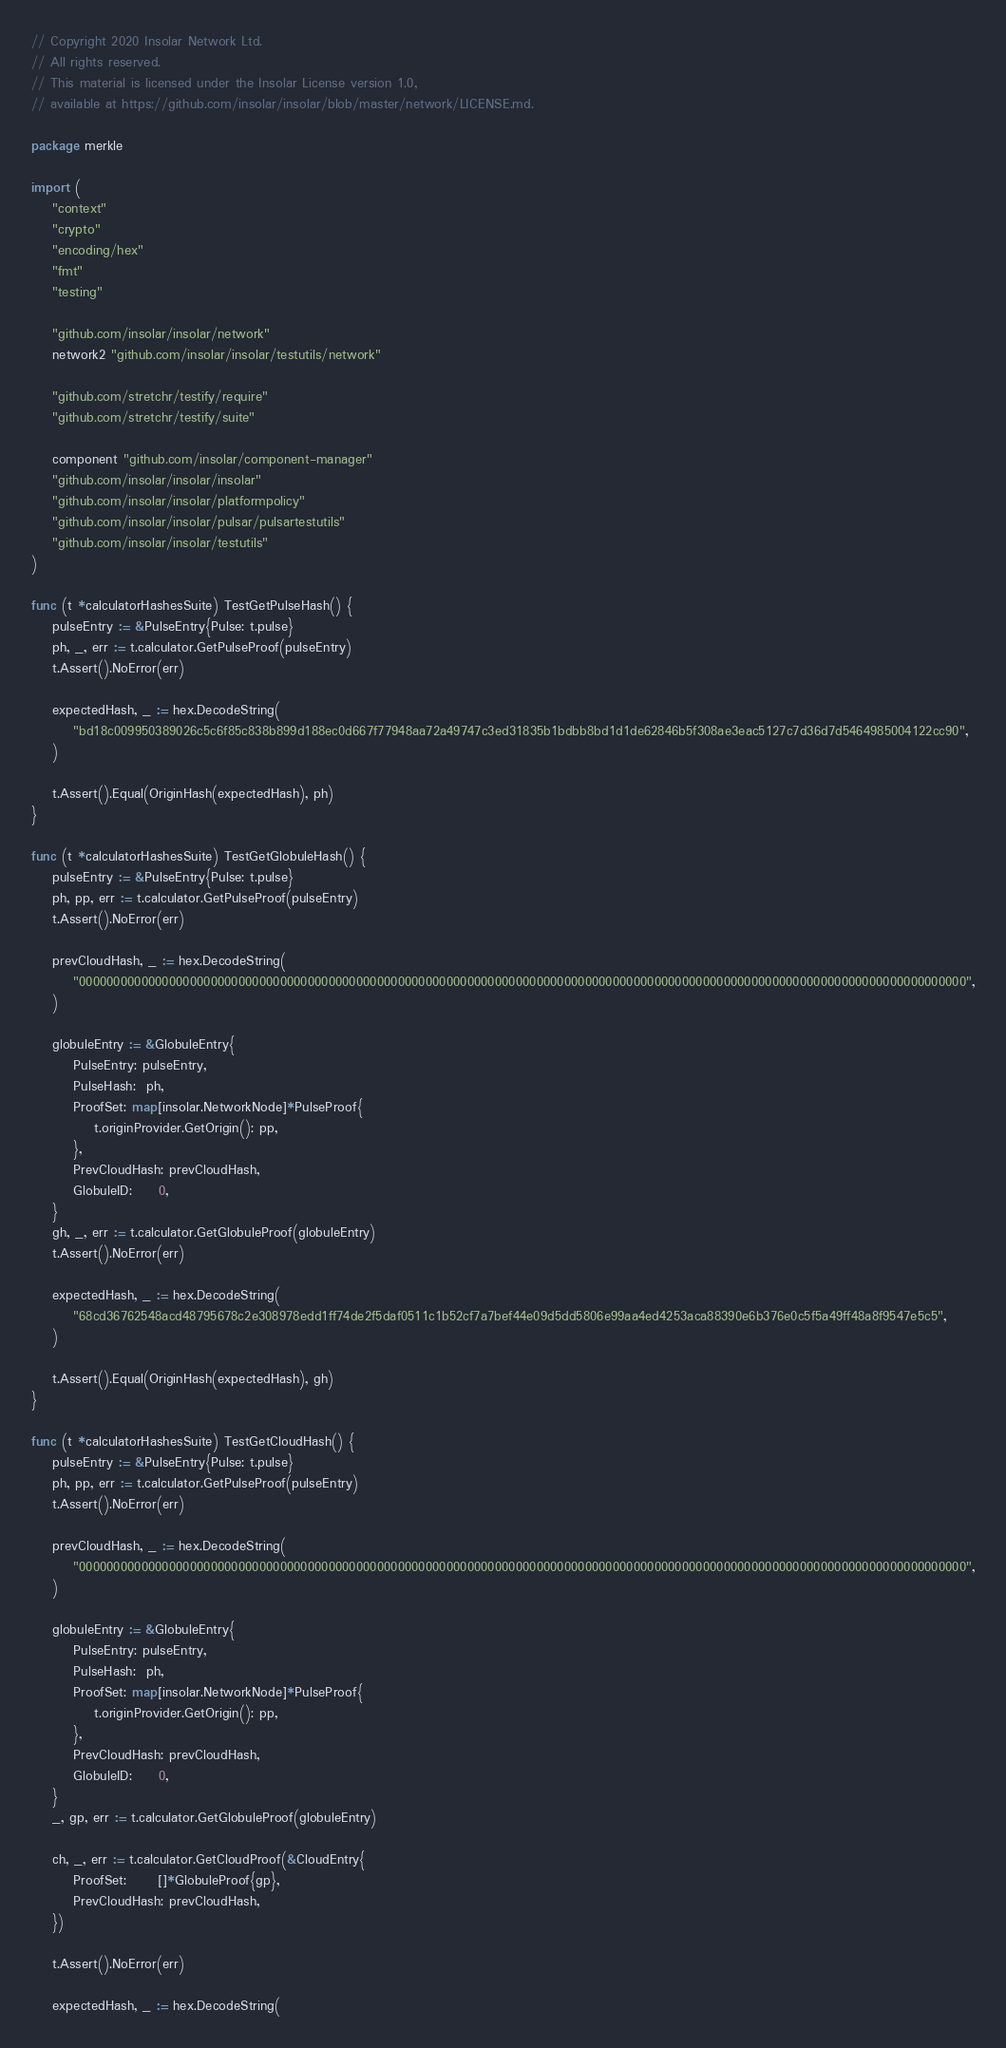<code> <loc_0><loc_0><loc_500><loc_500><_Go_>// Copyright 2020 Insolar Network Ltd.
// All rights reserved.
// This material is licensed under the Insolar License version 1.0,
// available at https://github.com/insolar/insolar/blob/master/network/LICENSE.md.

package merkle

import (
	"context"
	"crypto"
	"encoding/hex"
	"fmt"
	"testing"

	"github.com/insolar/insolar/network"
	network2 "github.com/insolar/insolar/testutils/network"

	"github.com/stretchr/testify/require"
	"github.com/stretchr/testify/suite"

	component "github.com/insolar/component-manager"
	"github.com/insolar/insolar/insolar"
	"github.com/insolar/insolar/platformpolicy"
	"github.com/insolar/insolar/pulsar/pulsartestutils"
	"github.com/insolar/insolar/testutils"
)

func (t *calculatorHashesSuite) TestGetPulseHash() {
	pulseEntry := &PulseEntry{Pulse: t.pulse}
	ph, _, err := t.calculator.GetPulseProof(pulseEntry)
	t.Assert().NoError(err)

	expectedHash, _ := hex.DecodeString(
		"bd18c009950389026c5c6f85c838b899d188ec0d667f77948aa72a49747c3ed31835b1bdbb8bd1d1de62846b5f308ae3eac5127c7d36d7d5464985004122cc90",
	)

	t.Assert().Equal(OriginHash(expectedHash), ph)
}

func (t *calculatorHashesSuite) TestGetGlobuleHash() {
	pulseEntry := &PulseEntry{Pulse: t.pulse}
	ph, pp, err := t.calculator.GetPulseProof(pulseEntry)
	t.Assert().NoError(err)

	prevCloudHash, _ := hex.DecodeString(
		"00000000000000000000000000000000000000000000000000000000000000000000000000000000000000000000000000000000000000000000000000000000",
	)

	globuleEntry := &GlobuleEntry{
		PulseEntry: pulseEntry,
		PulseHash:  ph,
		ProofSet: map[insolar.NetworkNode]*PulseProof{
			t.originProvider.GetOrigin(): pp,
		},
		PrevCloudHash: prevCloudHash,
		GlobuleID:     0,
	}
	gh, _, err := t.calculator.GetGlobuleProof(globuleEntry)
	t.Assert().NoError(err)

	expectedHash, _ := hex.DecodeString(
		"68cd36762548acd48795678c2e308978edd1ff74de2f5daf0511c1b52cf7a7bef44e09d5dd5806e99aa4ed4253aca88390e6b376e0c5f5a49ff48a8f9547e5c5",
	)

	t.Assert().Equal(OriginHash(expectedHash), gh)
}

func (t *calculatorHashesSuite) TestGetCloudHash() {
	pulseEntry := &PulseEntry{Pulse: t.pulse}
	ph, pp, err := t.calculator.GetPulseProof(pulseEntry)
	t.Assert().NoError(err)

	prevCloudHash, _ := hex.DecodeString(
		"00000000000000000000000000000000000000000000000000000000000000000000000000000000000000000000000000000000000000000000000000000000",
	)

	globuleEntry := &GlobuleEntry{
		PulseEntry: pulseEntry,
		PulseHash:  ph,
		ProofSet: map[insolar.NetworkNode]*PulseProof{
			t.originProvider.GetOrigin(): pp,
		},
		PrevCloudHash: prevCloudHash,
		GlobuleID:     0,
	}
	_, gp, err := t.calculator.GetGlobuleProof(globuleEntry)

	ch, _, err := t.calculator.GetCloudProof(&CloudEntry{
		ProofSet:      []*GlobuleProof{gp},
		PrevCloudHash: prevCloudHash,
	})

	t.Assert().NoError(err)

	expectedHash, _ := hex.DecodeString(</code> 